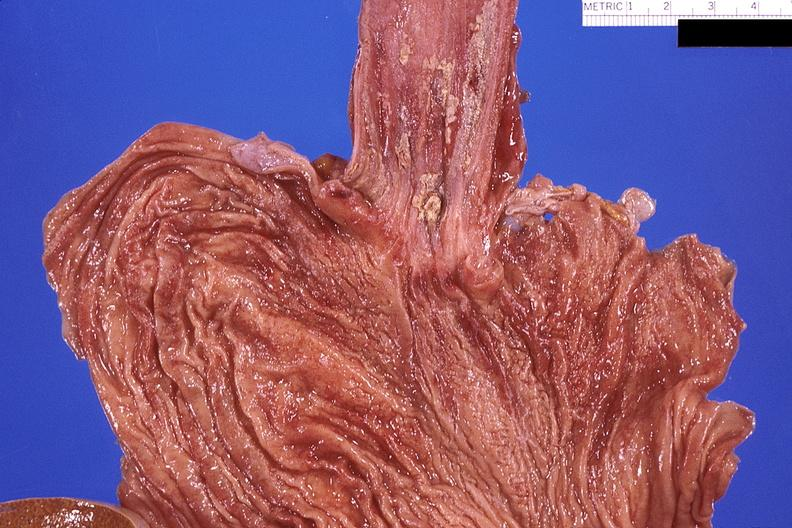does atrophy secondary to pituitectomy show esohagus, candida?
Answer the question using a single word or phrase. No 